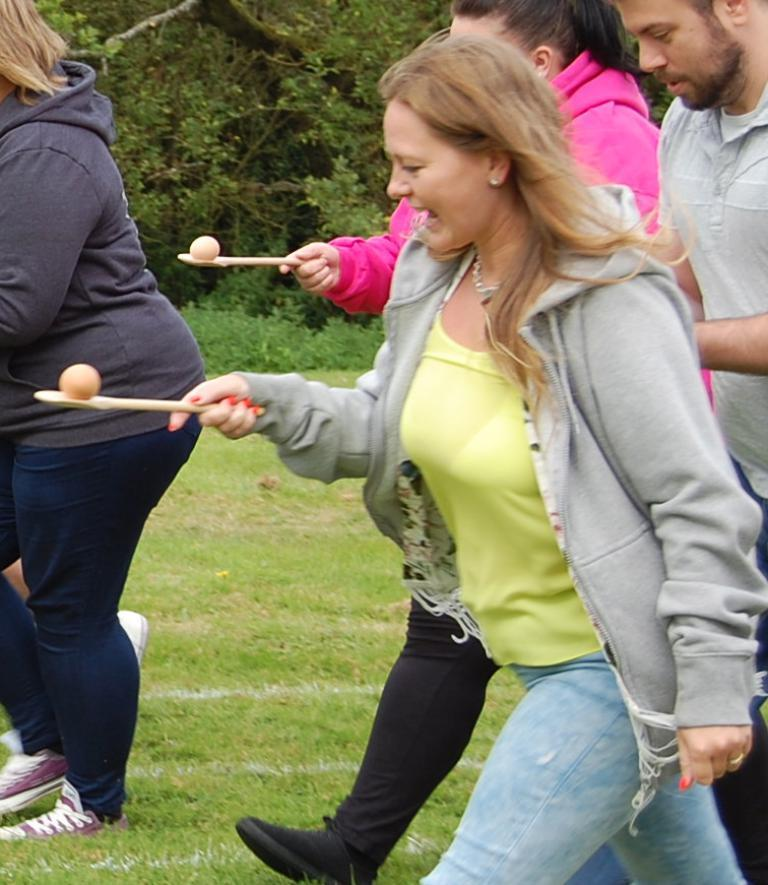How many people are walking on the grass in the image? There are four people walking on the grass in the image. What are two of the people holding? Two of the people are holding spoons with eggs on them. What can be seen in the background of the image? There are trees visible in the background. What type of plot is being used to grow the trees in the image? There is no information about a plot or how the trees are being grown in the image. 